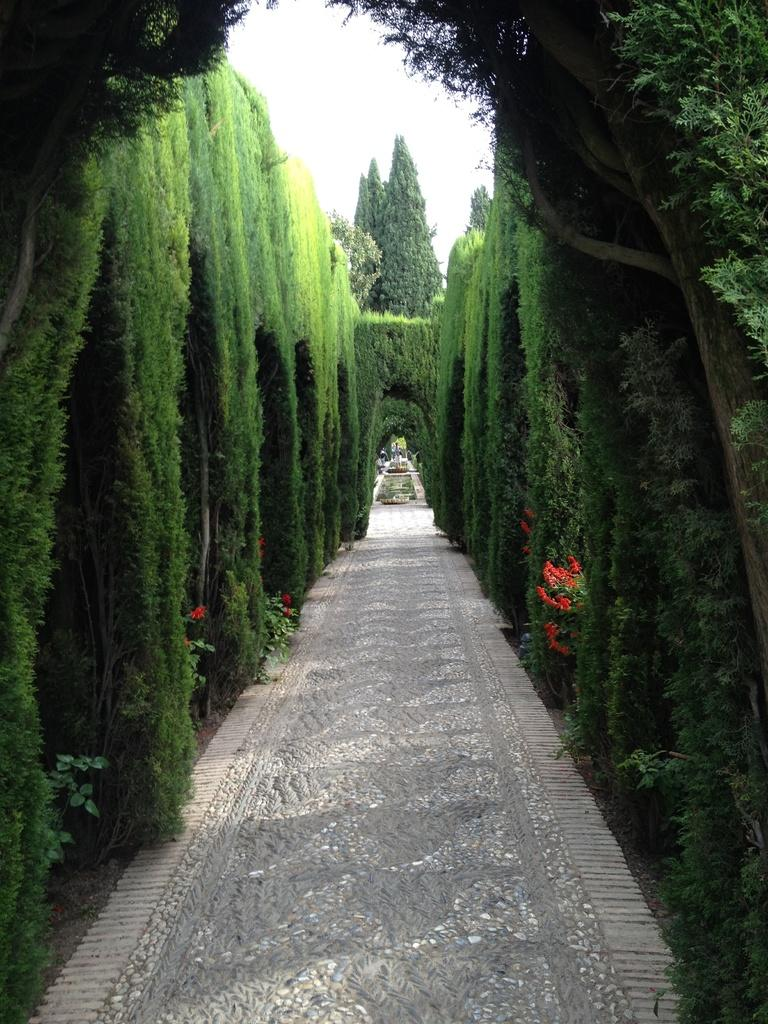What types of vegetation are present in the image? The image contains trees and plants. What can be seen at the bottom of the image? There is a path at the bottom of the image. What color are the flowers in the image? The flowers in the image are red. What is visible at the top of the image? The sky is visible at the top of the image. What type of office furniture can be seen in the image? There is no office furniture present in the image; it features trees, plants, flowers, a path, and the sky. In which direction is the image facing? The image does not have a specific direction, as it is a still image of a natural scene. 